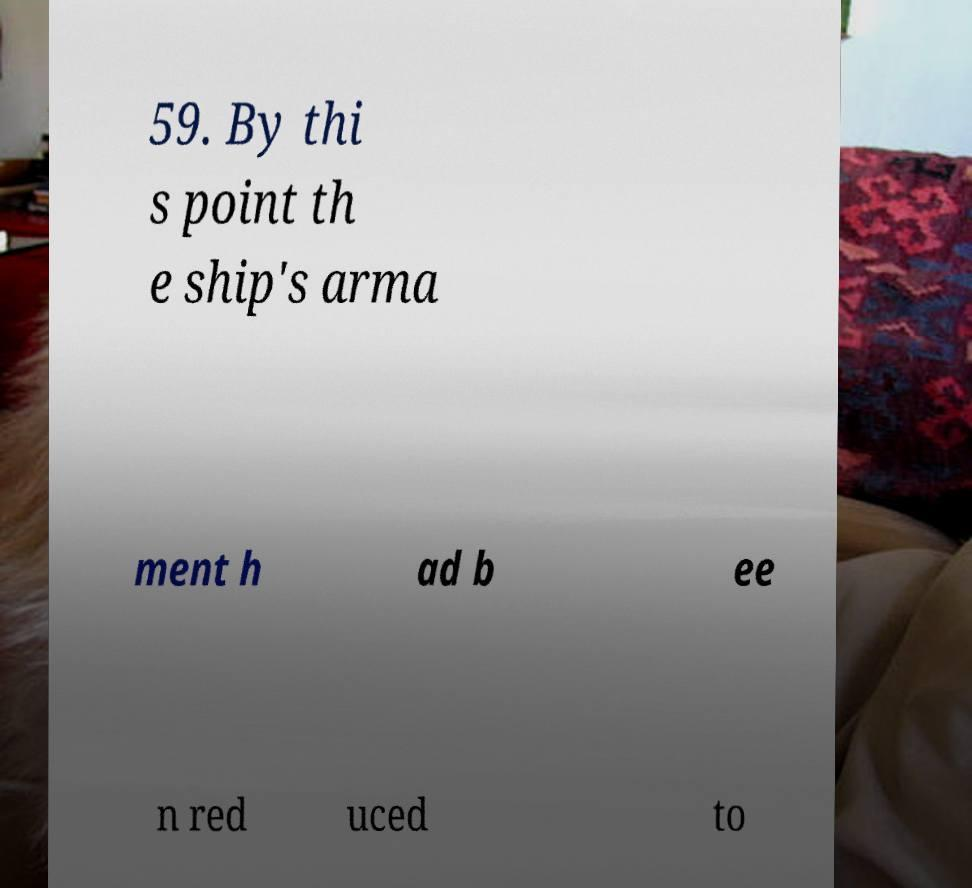Can you accurately transcribe the text from the provided image for me? 59. By thi s point th e ship's arma ment h ad b ee n red uced to 